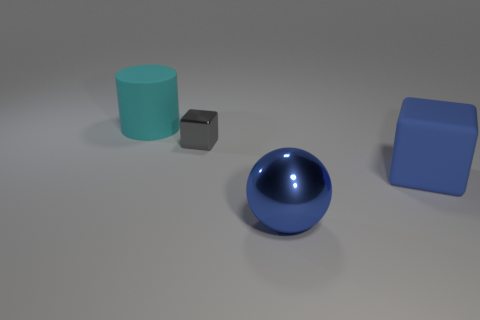There is a big rubber object that is to the right of the big blue metal thing; is there a big blue block behind it? no 